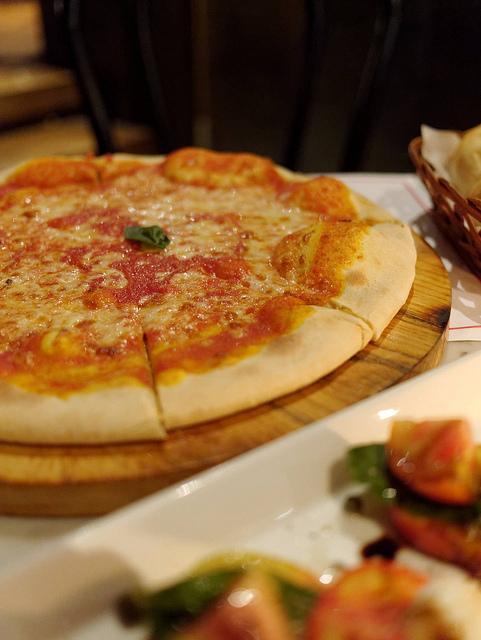How many chairs are there?
Give a very brief answer. 2. How many reflections of a cat are visible?
Give a very brief answer. 0. 